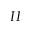Convert formula to latex. <formula><loc_0><loc_0><loc_500><loc_500>I I</formula> 